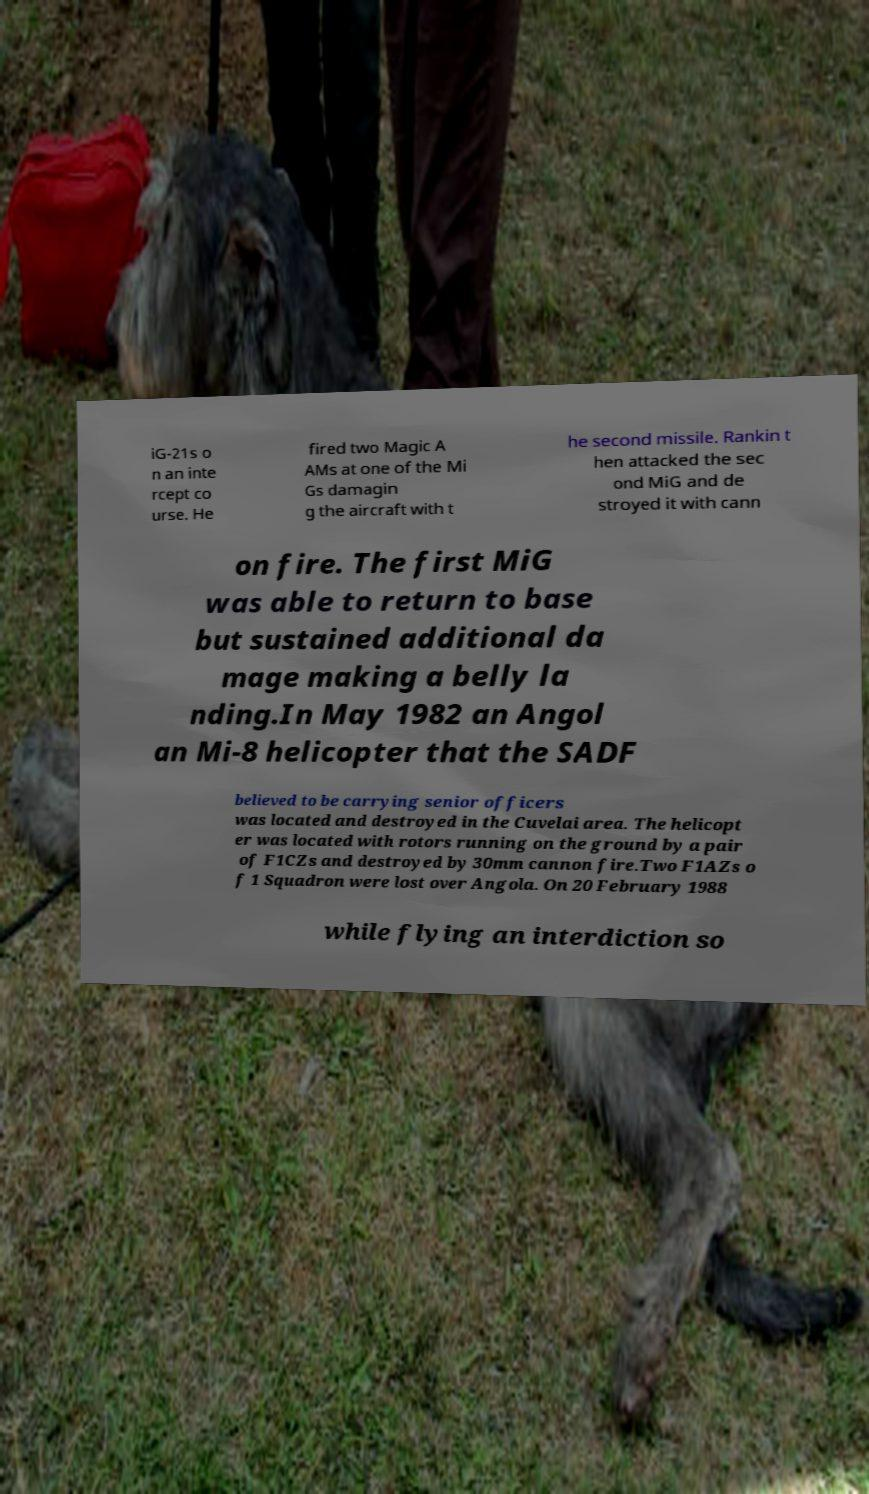For documentation purposes, I need the text within this image transcribed. Could you provide that? iG-21s o n an inte rcept co urse. He fired two Magic A AMs at one of the Mi Gs damagin g the aircraft with t he second missile. Rankin t hen attacked the sec ond MiG and de stroyed it with cann on fire. The first MiG was able to return to base but sustained additional da mage making a belly la nding.In May 1982 an Angol an Mi-8 helicopter that the SADF believed to be carrying senior officers was located and destroyed in the Cuvelai area. The helicopt er was located with rotors running on the ground by a pair of F1CZs and destroyed by 30mm cannon fire.Two F1AZs o f 1 Squadron were lost over Angola. On 20 February 1988 while flying an interdiction so 